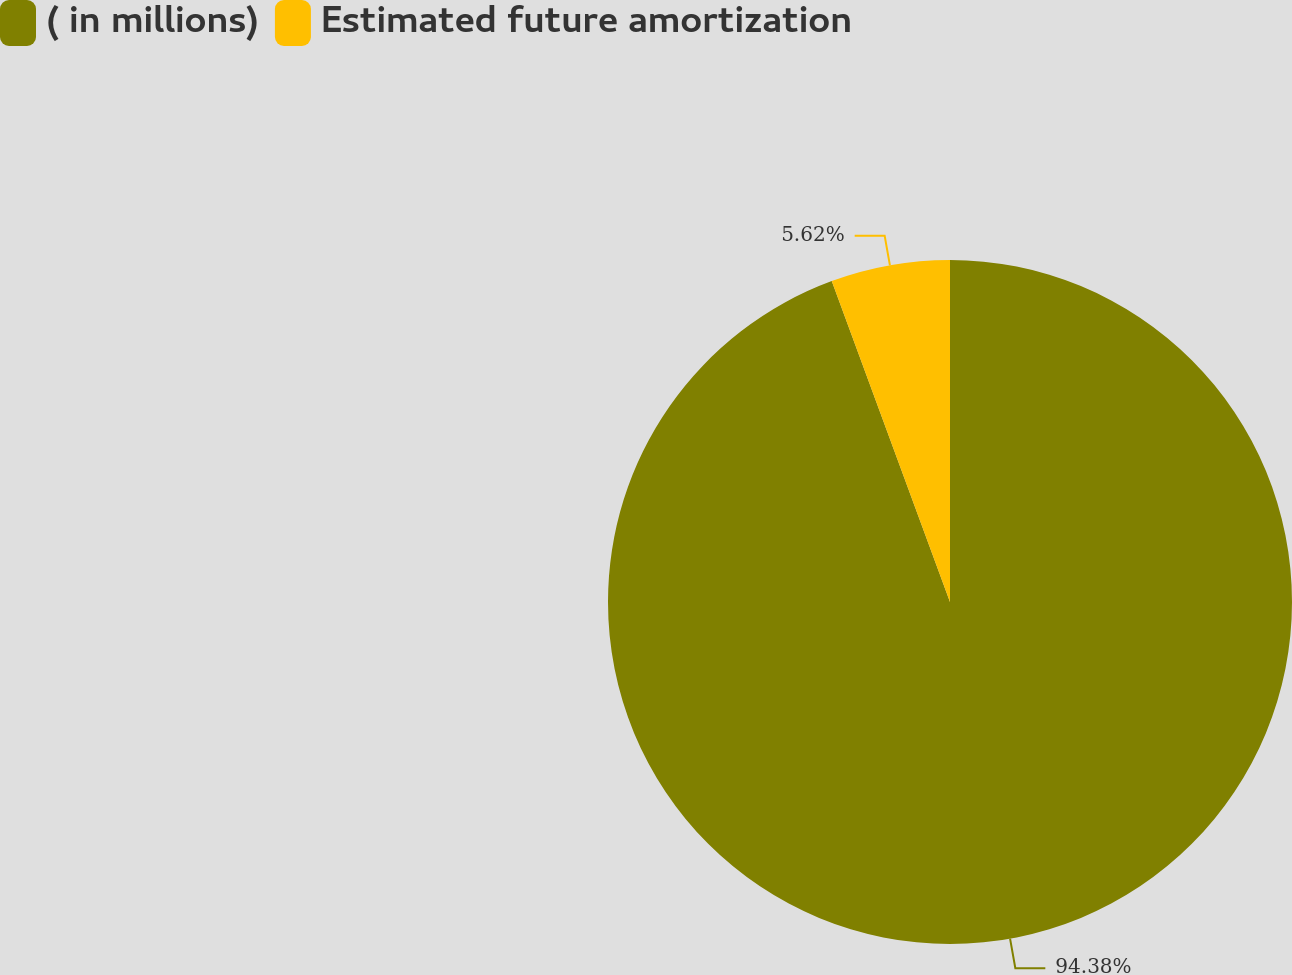<chart> <loc_0><loc_0><loc_500><loc_500><pie_chart><fcel>( in millions)<fcel>Estimated future amortization<nl><fcel>94.38%<fcel>5.62%<nl></chart> 